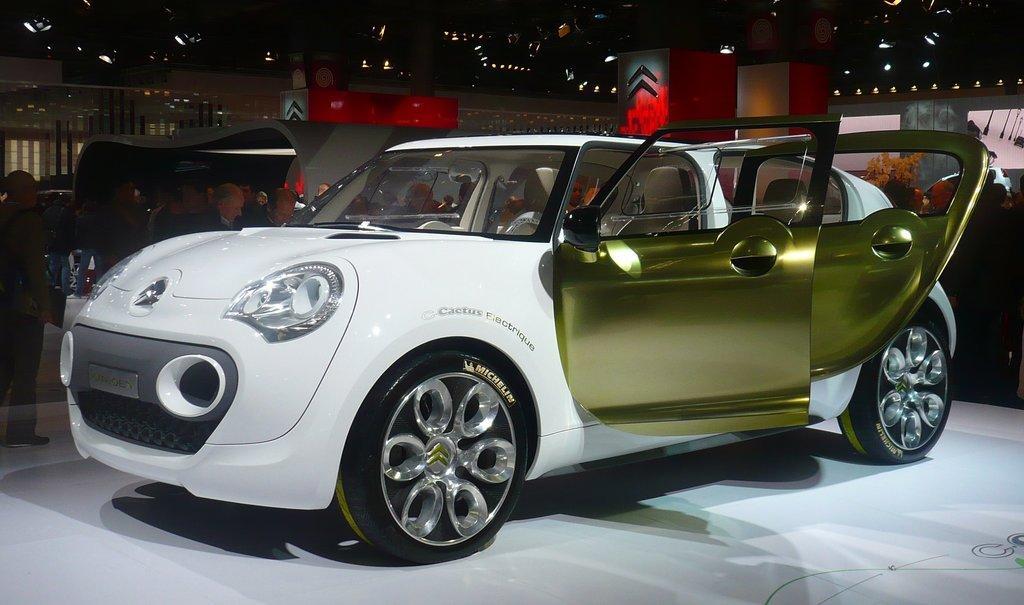Could you give a brief overview of what you see in this image? In this image there is a car on the floor. There are people standing on the floor. Right side there is a plant. Background there are buildings. There are vehicles on the floor. 